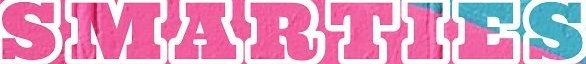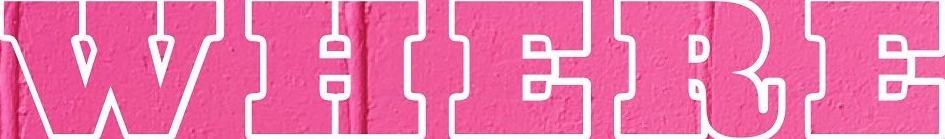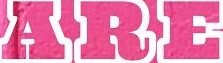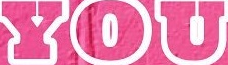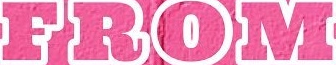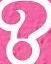What words can you see in these images in sequence, separated by a semicolon? SMARTIES; WHERE; ARE; YOU; FROM; ? 